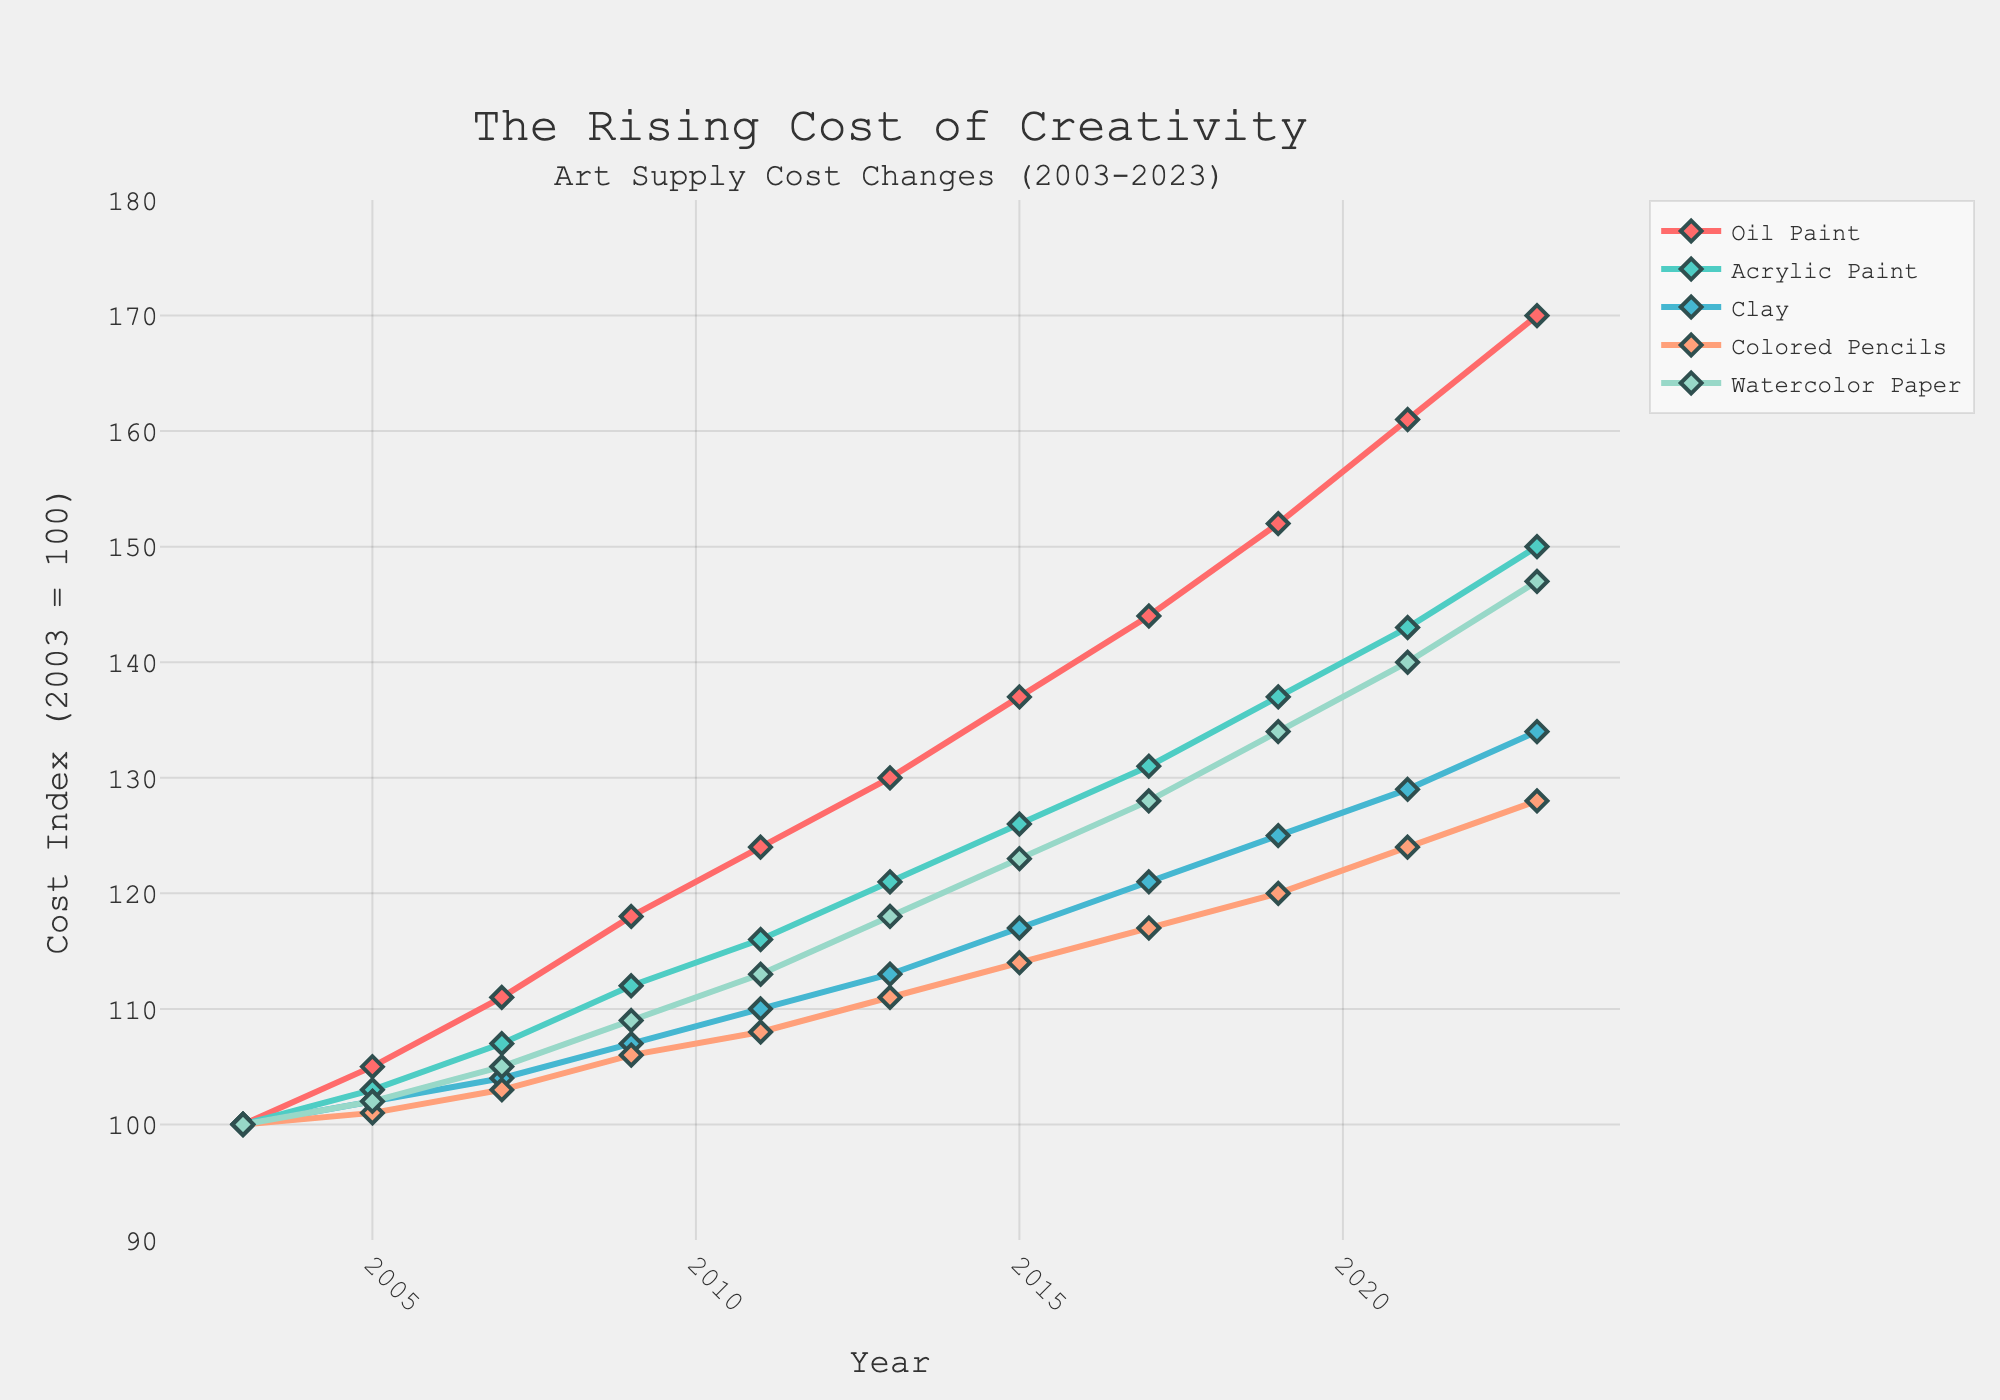Which medium has the highest cost in 2023? To find the highest cost in 2023, look at the values of all mediums for the year 2023. Oil Paint has the highest value at 170.
Answer: Oil Paint By how much did the cost of Acrylic Paint increase from 2003 to 2023? The cost of Acrylic Paint in 2003 was 100 and in 2023 it is 150. The difference is 150 - 100 = 50.
Answer: 50 Which medium experienced the smallest increase in cost from 2003 to 2023? Calculate the increase for each medium from 2003 to 2023 and compare them. Colored Pencils increased from 100 to 128, which is the smallest increase of 28.
Answer: Colored Pencils What is the average cost of Watercolor Paper over the 20-year period? Sum the Watercolor Paper costs from each year and divide by the number of years. The sum is 100 + 102 + 105 + 109 + 113 + 118 + 123 + 128 + 134 + 140 + 147 = 1319. Divide by 11 years, 1319 / 11 ≈ 119.9.
Answer: 119.9 Which medium had the most consistent cost increase over the years? The medium with the most consistent increase would show a steady and even rise in the plot. Acrylic Paint has a relatively smooth and consistent upward trend compared to others.
Answer: Acrylic Paint In which year did the cost of Clay first exceed 120? Scan the plot for the first year where the cost of Clay is above 120. In 2017, the cost of Clay is 121.
Answer: 2017 Compare the cost increase of Oil Paint vs. Clay between 2009 and 2019. Which increased more and by how much? Calculate the increase for both Oil Paint and Clay between 2009 and 2019. Oil Paint: 152 - 118 = 34, Clay: 125 - 107 = 18. Oil Paint increased more by 16.
Answer: Oil Paint by 16 What was the cost index of Colored Pencils in 2011 and how does it compare to Watercolor Paper in the same year? Check the values for 2011 for both Colored Pencils and Watercolor Paper. Colored Pencils was 108, Watercolor Paper was 113. Colored Pencils was 5 units less than Watercolor Paper.
Answer: 108, 5 units less By how much did the cost index of Watercolor Paper increase on average every 2 years between 2005 and 2015? Find the total increase between 2005 and 2015, then divide by the number of 2-year intervals. Increase: 123 - 102 = 21 over 10 years. Number of 2-year intervals is 5. Average increase per 2 years: 21 / 5 = 4.2.
Answer: 4.2 